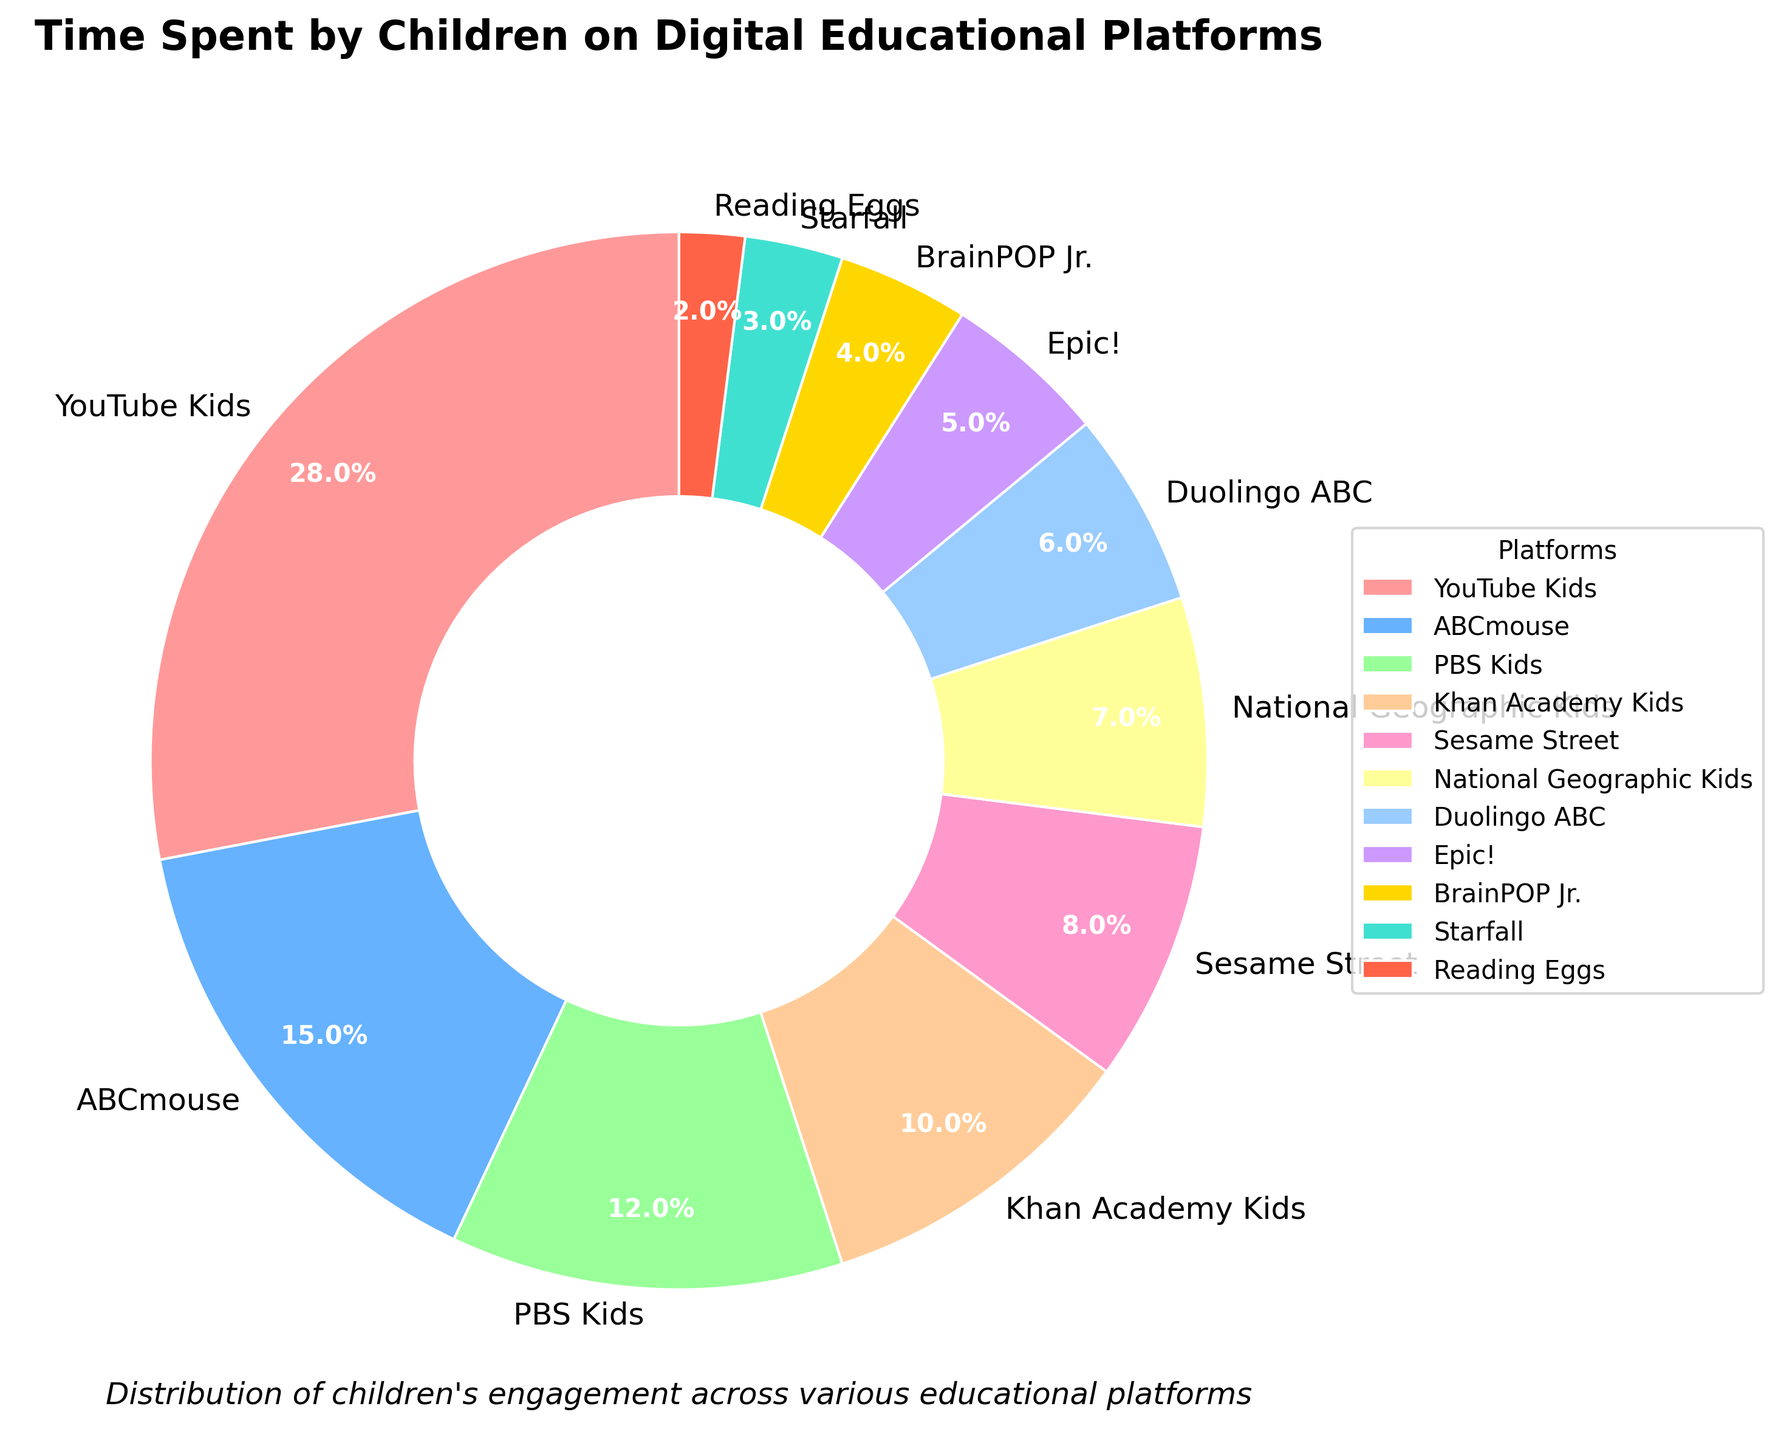What's the percentage of time spent on YouTube Kids? The pie chart shows that YouTube Kids constitutes 28% of the time spent by children on digital educational platforms.
Answer: 28% Which platform has the least time spent by children, and what percentage is it? By looking at the pie chart, we can identify that Reading Eggs has the smallest segment, indicating the least time spent at 2%.
Answer: Reading Eggs, 2% How much more time is spent on ABCmouse compared to Starfall? The chart depicts the percentage of time: ABCmouse is 15% and Starfall is 3%. To find how much more, subtract Starfall's percentage from ABCmouse's: 15% - 3% = 12%.
Answer: 12% What is the combined percentage of time spent on PBS Kids, Khan Academy Kids, and Sesame Street? Adding their respective percentages from the pie chart gives us: PBS Kids (12%) + Khan Academy Kids (10%) + Sesame Street (8%) = 12% + 10% + 8% = 30%.
Answer: 30% Is time spent on National Geographic Kids greater than that on Duolingo ABC? National Geographic Kids takes up 7% of the time, whereas Duolingo ABC occupies 6%. 7% is greater than 6%, so the answer is yes.
Answer: Yes Which two platforms combined share the same percentage as YouTube Kids alone? YouTube Kids has 28%. Adding ABCmouse and PBS Kids gives: ABCmouse (15%) + PBS Kids (12%) = 15% + 12% = 27%. Thus, no two platforms exactly match YouTube Kids' percentage, but ABCmouse and PBS Kids come closest.
Answer: ABCmouse and PBS Kids What is the percentage difference between time spent on BrainPOP Jr. and Khan Academy Kids? The pie chart shows that BrainPOP Jr. has 4% and Khan Academy Kids has 10%. To find the difference: 10% - 4% = 6%.
Answer: 6% What percentage of time is spent on platforms other than YouTube Kids and ABCmouse? To find this, subtract the sum of YouTube Kids and ABCmouse from 100%: 100% - (28% + 15%) = 100% - 43% = 57%.
Answer: 57% Is the percentage of time spent on Epic! greater than that on Reading Eggs and Starfall combined? The chart shows Epic! at 5%, Reading Eggs at 2%, and Starfall at 3%. Combined, Reading Eggs and Starfall total 5% (2% + 3%), which is equal to the time spent on Epic!.
Answer: No, it's equal How does time spent on Sesame Street compare to BrainPOP Jr. and Starfall combined? Sesame Street has 8% while BrainPOP Jr. (4%) and Starfall (3%) combined total 7% (4% + 3%). Thus, Sesame Street’s percentage is 1% higher.
Answer: 1% higher 